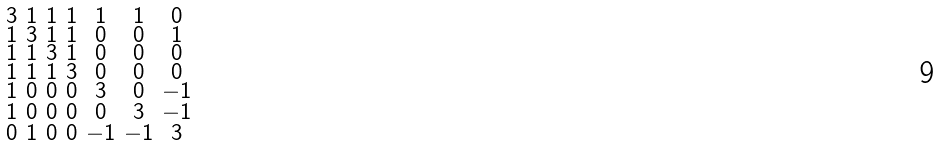<formula> <loc_0><loc_0><loc_500><loc_500>\begin{smallmatrix} 3 & 1 & 1 & 1 & 1 & 1 & 0 \\ 1 & 3 & 1 & 1 & 0 & 0 & 1 \\ 1 & 1 & 3 & 1 & 0 & 0 & 0 \\ 1 & 1 & 1 & 3 & 0 & 0 & 0 \\ 1 & 0 & 0 & 0 & 3 & 0 & - 1 \\ 1 & 0 & 0 & 0 & 0 & 3 & - 1 \\ 0 & 1 & 0 & 0 & - 1 & - 1 & 3 \end{smallmatrix}</formula> 